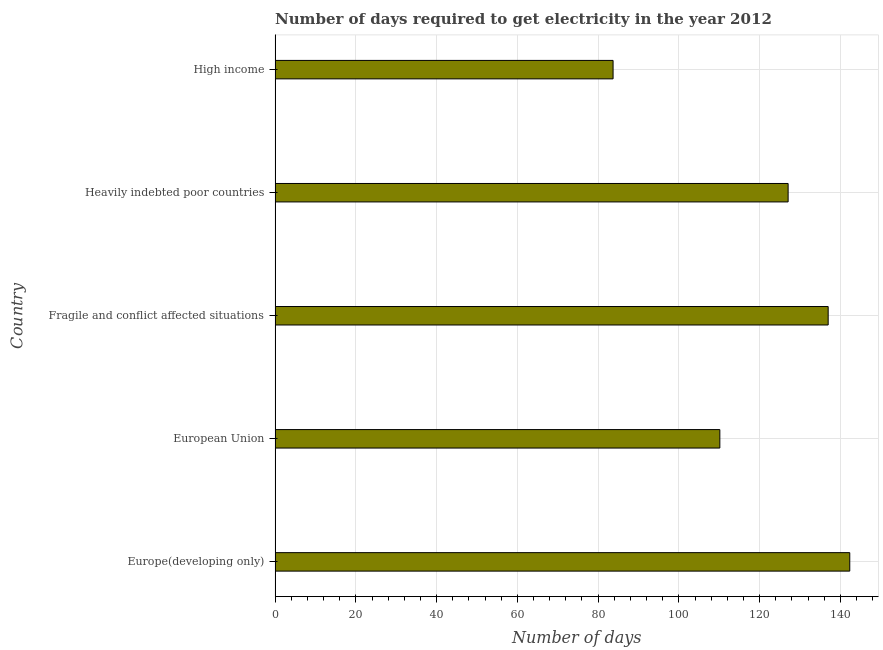What is the title of the graph?
Your answer should be compact. Number of days required to get electricity in the year 2012. What is the label or title of the X-axis?
Your response must be concise. Number of days. What is the time to get electricity in High income?
Your answer should be compact. 83.7. Across all countries, what is the maximum time to get electricity?
Keep it short and to the point. 142.32. Across all countries, what is the minimum time to get electricity?
Keep it short and to the point. 83.7. In which country was the time to get electricity maximum?
Your answer should be compact. Europe(developing only). What is the sum of the time to get electricity?
Keep it short and to the point. 600.18. What is the difference between the time to get electricity in Europe(developing only) and Fragile and conflict affected situations?
Make the answer very short. 5.35. What is the average time to get electricity per country?
Your response must be concise. 120.04. What is the median time to get electricity?
Offer a terse response. 127.05. In how many countries, is the time to get electricity greater than 40 ?
Provide a short and direct response. 5. What is the ratio of the time to get electricity in European Union to that in High income?
Provide a succinct answer. 1.32. What is the difference between the highest and the second highest time to get electricity?
Provide a succinct answer. 5.35. Is the sum of the time to get electricity in Fragile and conflict affected situations and High income greater than the maximum time to get electricity across all countries?
Make the answer very short. Yes. What is the difference between the highest and the lowest time to get electricity?
Keep it short and to the point. 58.61. In how many countries, is the time to get electricity greater than the average time to get electricity taken over all countries?
Keep it short and to the point. 3. How many bars are there?
Provide a succinct answer. 5. Are all the bars in the graph horizontal?
Offer a terse response. Yes. How many countries are there in the graph?
Give a very brief answer. 5. What is the Number of days of Europe(developing only)?
Give a very brief answer. 142.32. What is the Number of days in European Union?
Provide a short and direct response. 110.14. What is the Number of days in Fragile and conflict affected situations?
Keep it short and to the point. 136.97. What is the Number of days in Heavily indebted poor countries?
Make the answer very short. 127.05. What is the Number of days of High income?
Make the answer very short. 83.7. What is the difference between the Number of days in Europe(developing only) and European Union?
Your answer should be compact. 32.17. What is the difference between the Number of days in Europe(developing only) and Fragile and conflict affected situations?
Your answer should be compact. 5.35. What is the difference between the Number of days in Europe(developing only) and Heavily indebted poor countries?
Give a very brief answer. 15.26. What is the difference between the Number of days in Europe(developing only) and High income?
Provide a succinct answer. 58.61. What is the difference between the Number of days in European Union and Fragile and conflict affected situations?
Ensure brevity in your answer.  -26.83. What is the difference between the Number of days in European Union and Heavily indebted poor countries?
Provide a succinct answer. -16.91. What is the difference between the Number of days in European Union and High income?
Keep it short and to the point. 26.44. What is the difference between the Number of days in Fragile and conflict affected situations and Heavily indebted poor countries?
Ensure brevity in your answer.  9.92. What is the difference between the Number of days in Fragile and conflict affected situations and High income?
Provide a short and direct response. 53.27. What is the difference between the Number of days in Heavily indebted poor countries and High income?
Your response must be concise. 43.35. What is the ratio of the Number of days in Europe(developing only) to that in European Union?
Provide a succinct answer. 1.29. What is the ratio of the Number of days in Europe(developing only) to that in Fragile and conflict affected situations?
Offer a terse response. 1.04. What is the ratio of the Number of days in Europe(developing only) to that in Heavily indebted poor countries?
Give a very brief answer. 1.12. What is the ratio of the Number of days in European Union to that in Fragile and conflict affected situations?
Ensure brevity in your answer.  0.8. What is the ratio of the Number of days in European Union to that in Heavily indebted poor countries?
Provide a short and direct response. 0.87. What is the ratio of the Number of days in European Union to that in High income?
Offer a very short reply. 1.32. What is the ratio of the Number of days in Fragile and conflict affected situations to that in Heavily indebted poor countries?
Your answer should be compact. 1.08. What is the ratio of the Number of days in Fragile and conflict affected situations to that in High income?
Offer a terse response. 1.64. What is the ratio of the Number of days in Heavily indebted poor countries to that in High income?
Provide a succinct answer. 1.52. 